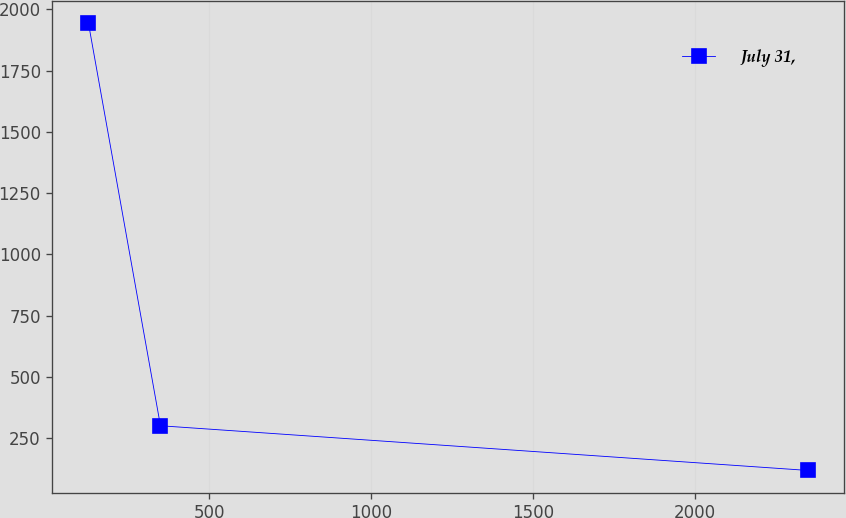Convert chart. <chart><loc_0><loc_0><loc_500><loc_500><line_chart><ecel><fcel>July 31,<nl><fcel>127.64<fcel>1942.25<nl><fcel>349.9<fcel>300.62<nl><fcel>2350.2<fcel>118.22<nl></chart> 